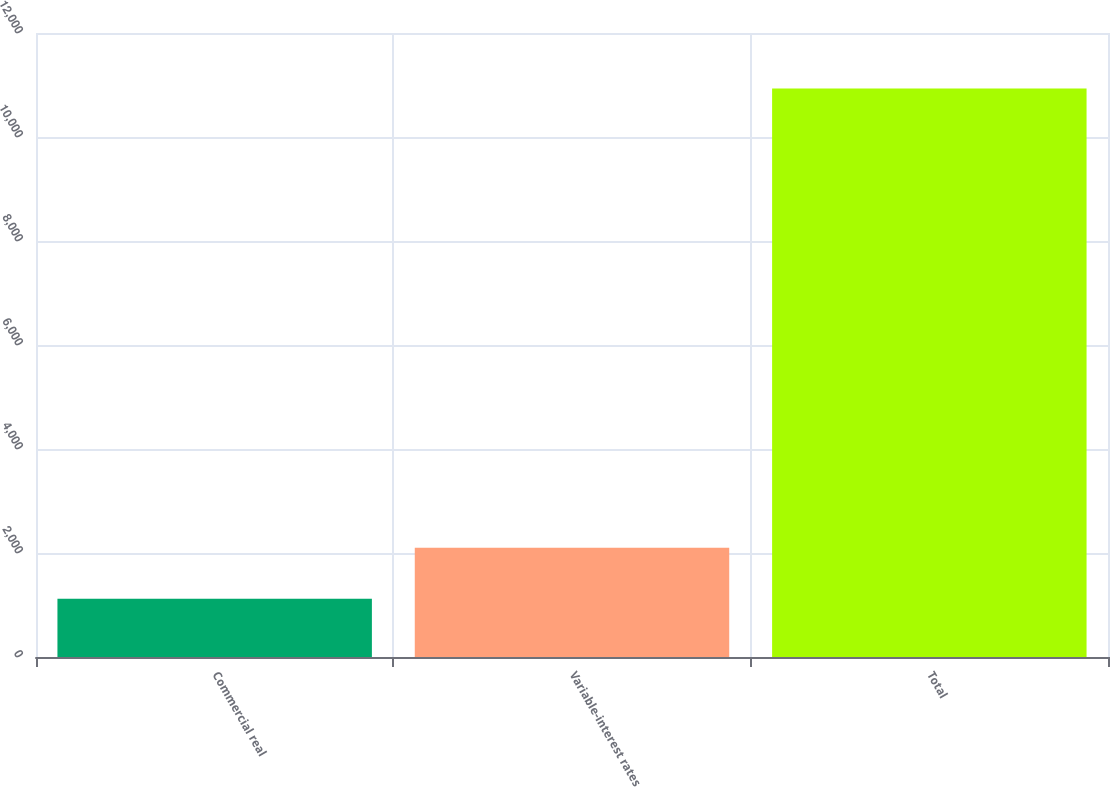<chart> <loc_0><loc_0><loc_500><loc_500><bar_chart><fcel>Commercial real<fcel>Variable-interest rates<fcel>Total<nl><fcel>1119<fcel>2100.2<fcel>10931<nl></chart> 